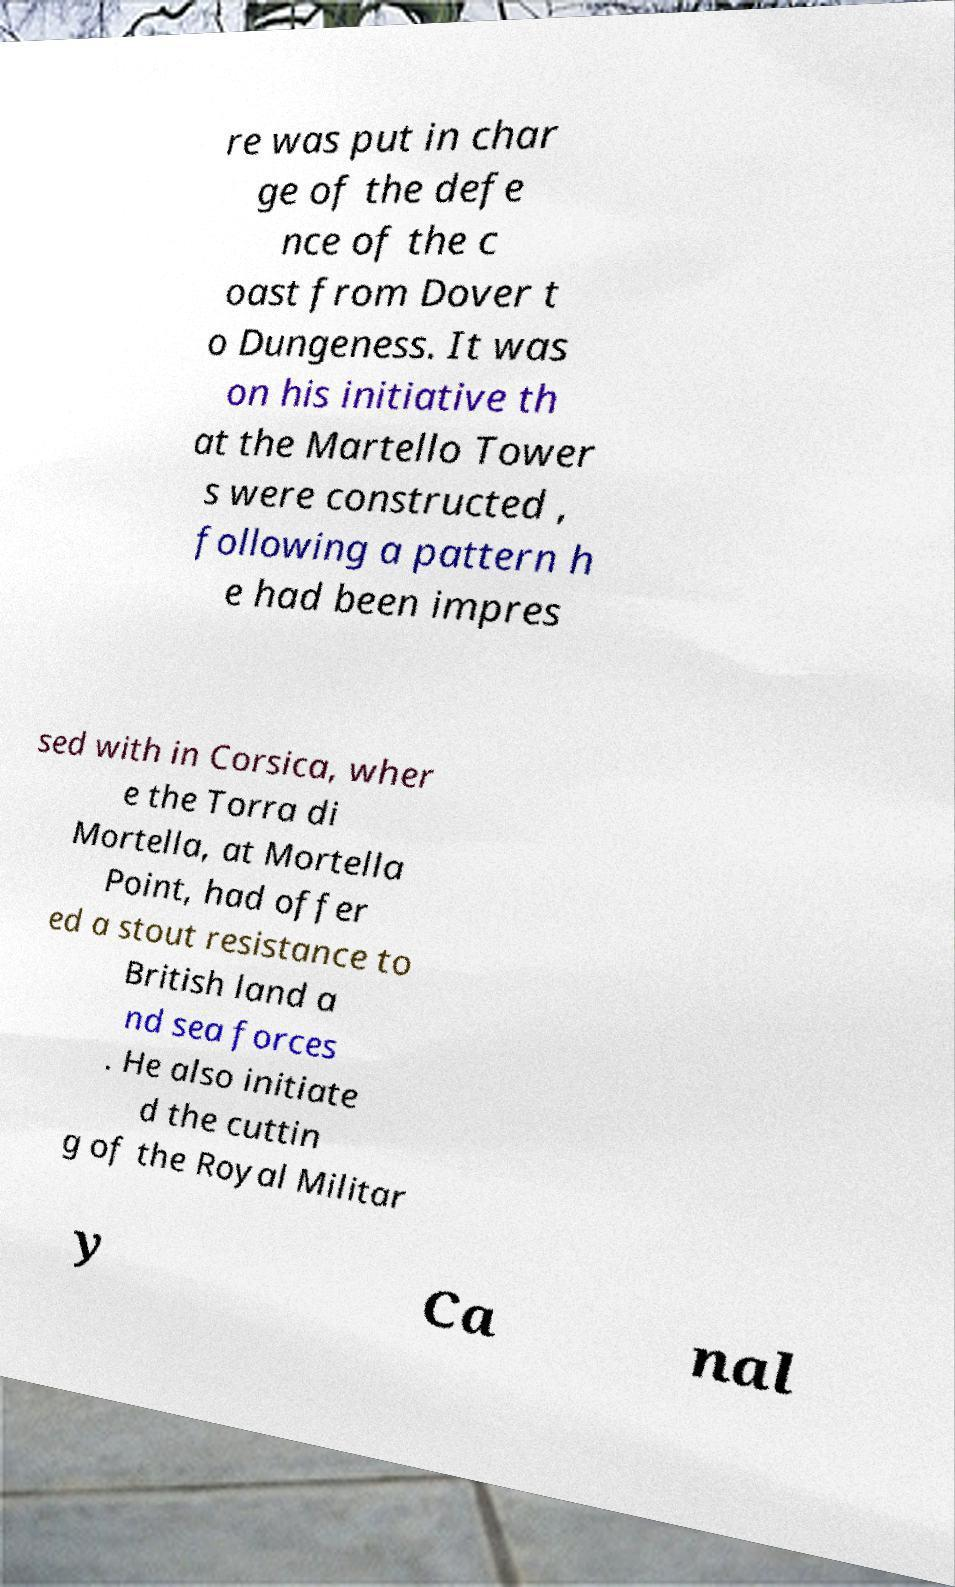Could you assist in decoding the text presented in this image and type it out clearly? re was put in char ge of the defe nce of the c oast from Dover t o Dungeness. It was on his initiative th at the Martello Tower s were constructed , following a pattern h e had been impres sed with in Corsica, wher e the Torra di Mortella, at Mortella Point, had offer ed a stout resistance to British land a nd sea forces . He also initiate d the cuttin g of the Royal Militar y Ca nal 